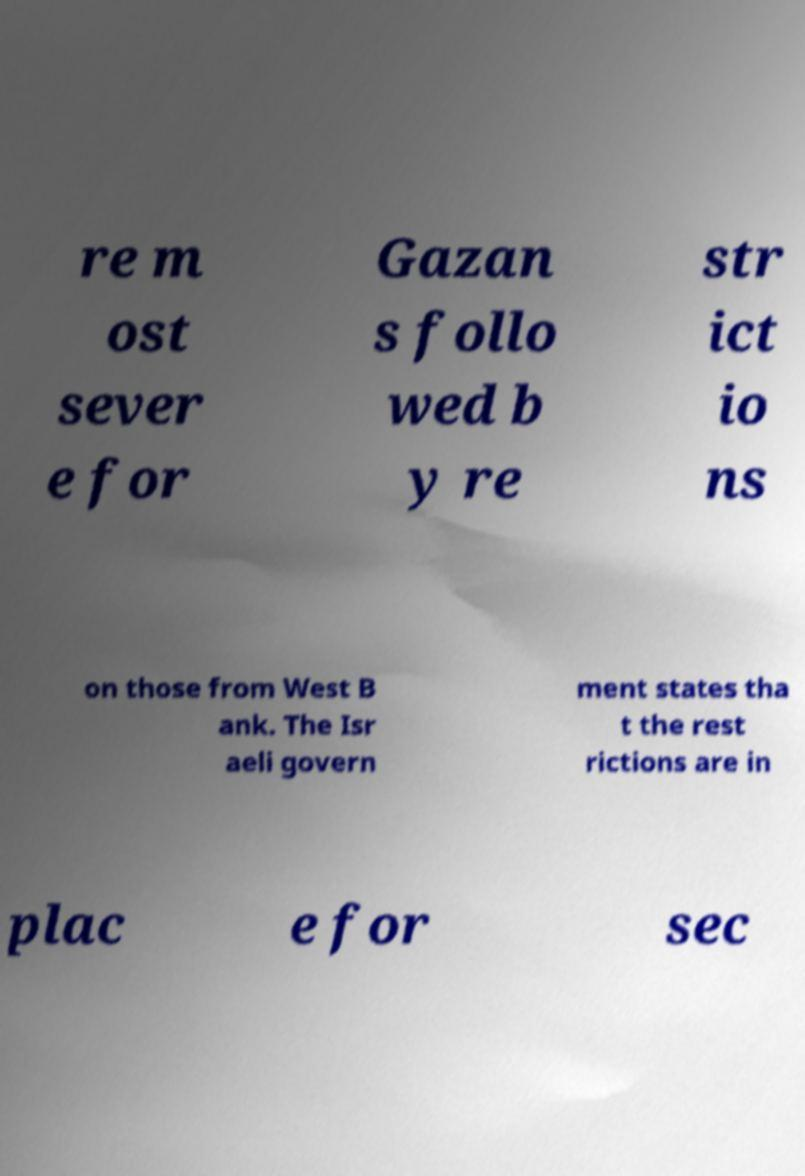Could you extract and type out the text from this image? re m ost sever e for Gazan s follo wed b y re str ict io ns on those from West B ank. The Isr aeli govern ment states tha t the rest rictions are in plac e for sec 